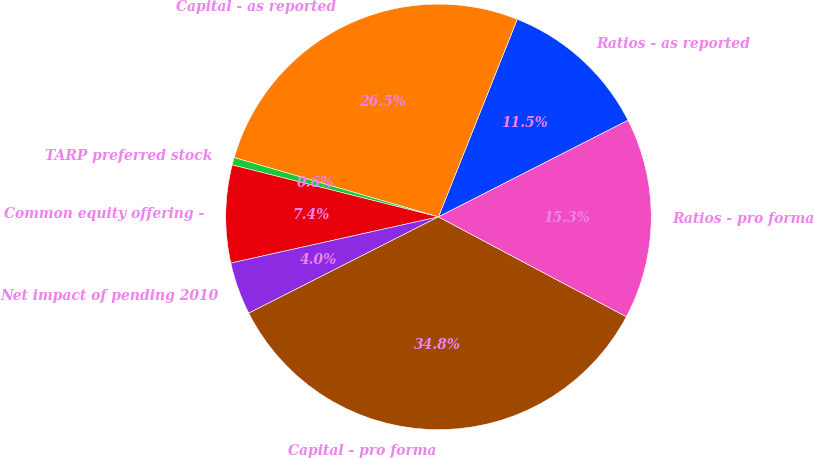<chart> <loc_0><loc_0><loc_500><loc_500><pie_chart><fcel>Ratios - as reported<fcel>Capital - as reported<fcel>TARP preferred stock<fcel>Common equity offering -<fcel>Net impact of pending 2010<fcel>Capital - pro forma<fcel>Ratios - pro forma<nl><fcel>11.46%<fcel>26.54%<fcel>0.57%<fcel>7.41%<fcel>3.99%<fcel>34.75%<fcel>15.28%<nl></chart> 